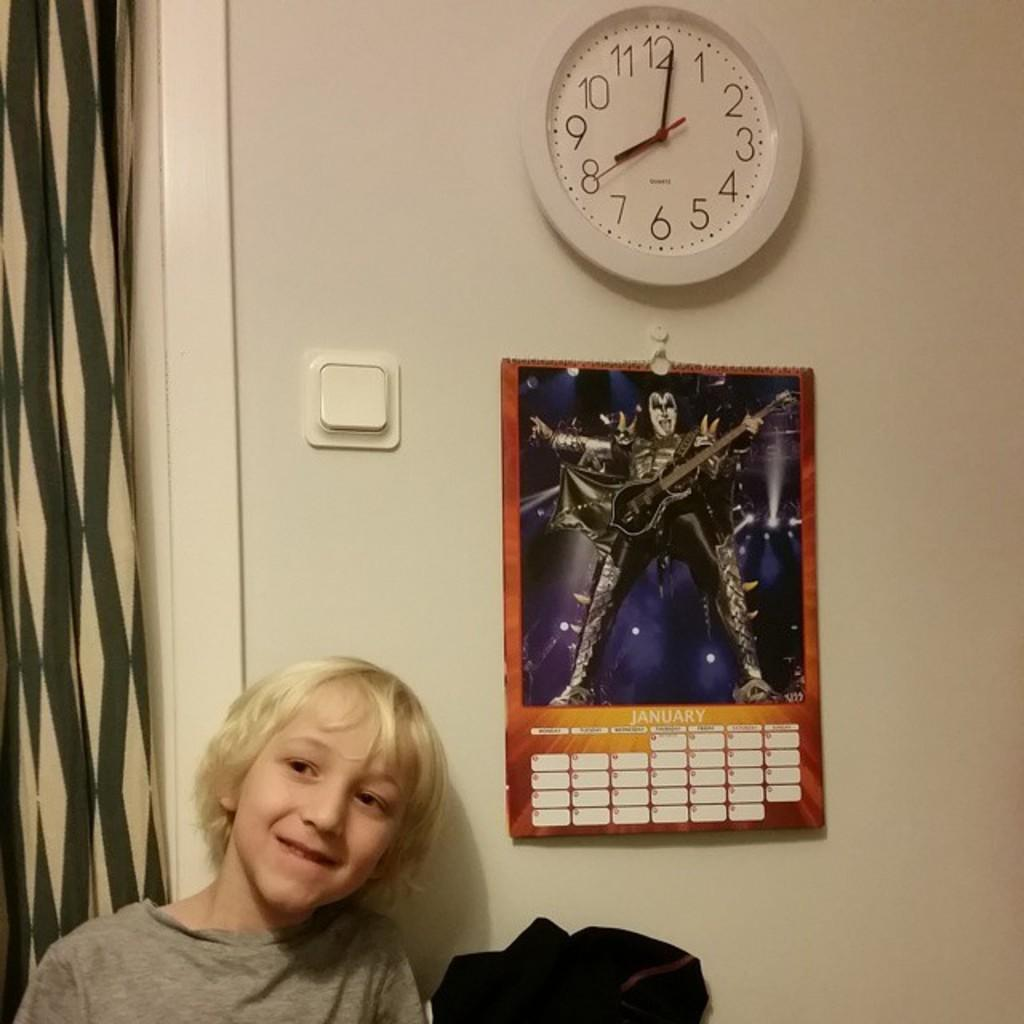Provide a one-sentence caption for the provided image. a kid near a wall that has a KISS calendar and clock at 8:00. 